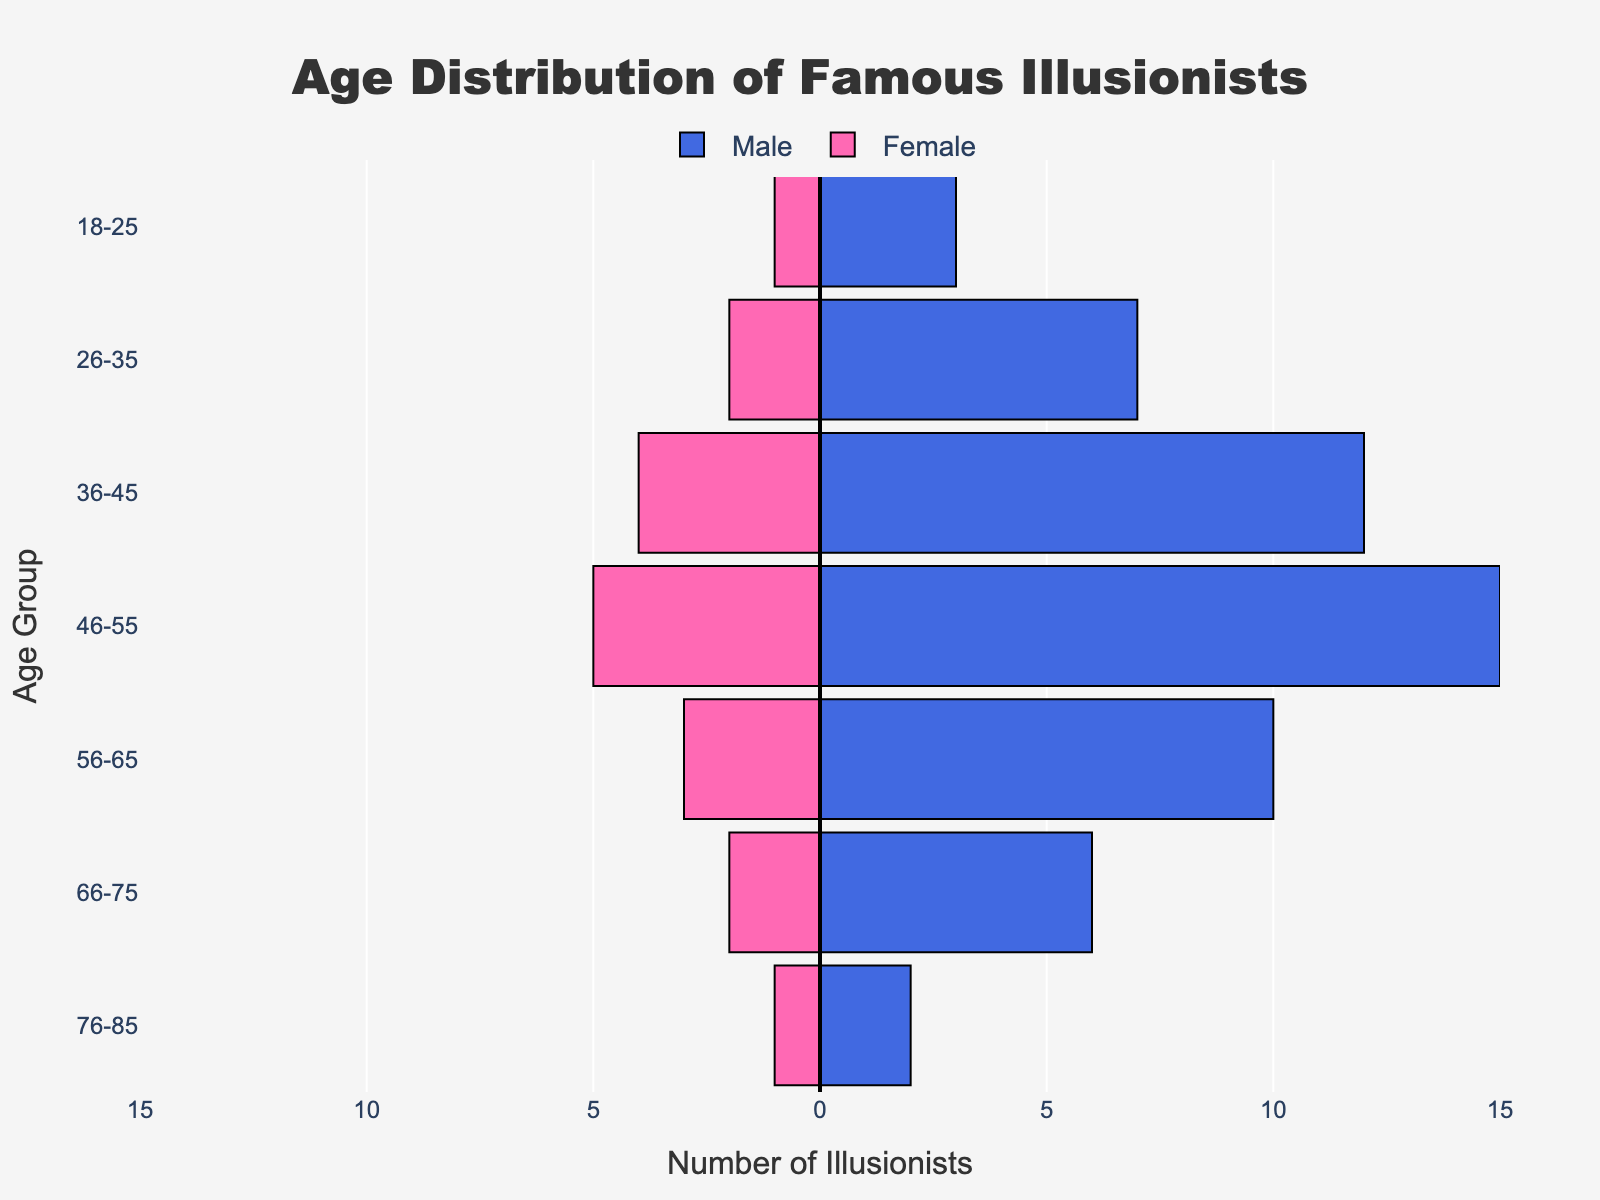what is the title of the figure? The title of the figure is prominently placed at the top center of the chart. It states the theme or the subject of the plot, which helps the viewers immediately understand what the visualization is displaying.
Answer: Age Distribution of Famous Illusionists How many age groups are displayed for both male and female illusionists? By counting the distinct categories listed on the y-axis of the population pyramid, we can determine the number of age groups.
Answer: 7 Which age group has the highest number of male illusionists? By examining the length of the blue bars representing the male illusionists, we can compare the different age groups to find the one with the longest bar.
Answer: 46-55 What is the difference in the number of male and female illusionists in the age group 36-45? To find this, first locate the values for both genders in the age group 36-45, then subtract the number of female illusionists from the number of male illusionists: 12 (male) - 4 (female) = 8.
Answer: 8 Which age group shows the smallest absolute difference between male and female illusionists? Calculate the absolute difference between male and female illusionists for each age group and compare them: 
- 18-25: abs(3-1) = 2
- 26-35: abs(7-2) = 5
- 36-45: abs(12-4) = 8
- 46-55: abs(15-5) = 10
- 56-65: abs(10-3) = 7
- 66-75: abs(6-2) = 4
- 76-85: abs(2-1) = 1. 
The smallest difference is in the age group 76-85.
Answer: 76-85 How are the female illusionists visually represented in the chart? Female illusionists are represented by pink bars that extend to the left side of the vertical line (x=0). The number of female illusionists is shown as negative values on the x-axis.
Answer: Pink bars extending left What can you infer about the trends of male and female illusionists as they age? By observing the overall shape and length of the bars for both genders across the age groups, we can infer that the number of male illusionists generally peaks in the 46-55 age group and then declines. Female illusionists follow a similar pattern but have consistently fewer individuals in each age group.
Answer: Peak in middle age, decline with age Between the age groups 56-65 and 18-25, which has more total illusionists, and by how many? Sum the numbers for both genders in the age groups 56-65 and 18-25 and compare them:
- 56-65: 10 (male) + 3 (female) = 13
- 18-25: 3 (male) + 1 (female) = 4.
56-65 has more illusionists. The difference is 13 - 4 = 9.
Answer: 56-65 by 9 What proportion of the total number of illusionists in the age group 46-55 are female? First, calculate the total number of illusionists in the age group 46-55:
15 (male) + 5 (female) = 20. 
Next, determine the proportion of female illusionists: 
5 (female) / 20 (total) = 0.25 or 25%.
Answer: 25% How do the color choices help in distinguishing between the genders in this plot? The color choices in the population pyramid make it easy to distinguish between male and female illusionists by using blue for males and pink for females. This clear differentiation through color enhances the visual comprehension of the data.
Answer: Clear gender differentiation through color 